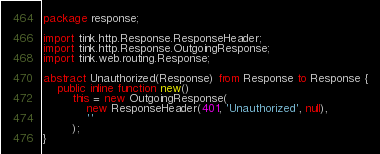Convert code to text. <code><loc_0><loc_0><loc_500><loc_500><_Haxe_>package response;

import tink.http.Response.ResponseHeader;
import tink.http.Response.OutgoingResponse;
import tink.web.routing.Response;

abstract Unauthorized(Response) from Response to Response {
    public inline function new()
        this = new OutgoingResponse(
            new ResponseHeader(401, 'Unauthorized', null),
            ''
        );
}</code> 